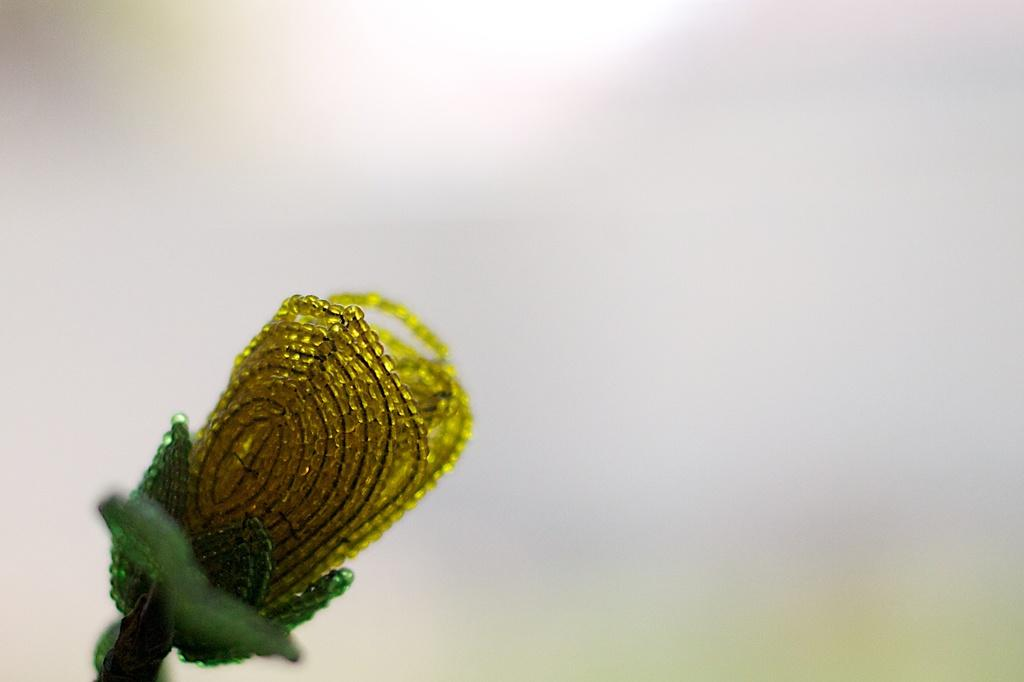What is the main subject of the image? The main subject of the image is a flower. What colors are used to create the flower? The flower is made up of objects that are yellow and green in color. What color is the background of the image? The background of the image is white. Where is the fireman standing in the image? There is no fireman present in the image; it features a flower made up of yellow and green objects against a white background. What type of boot is visible in the image? There are no boots present in the image. 